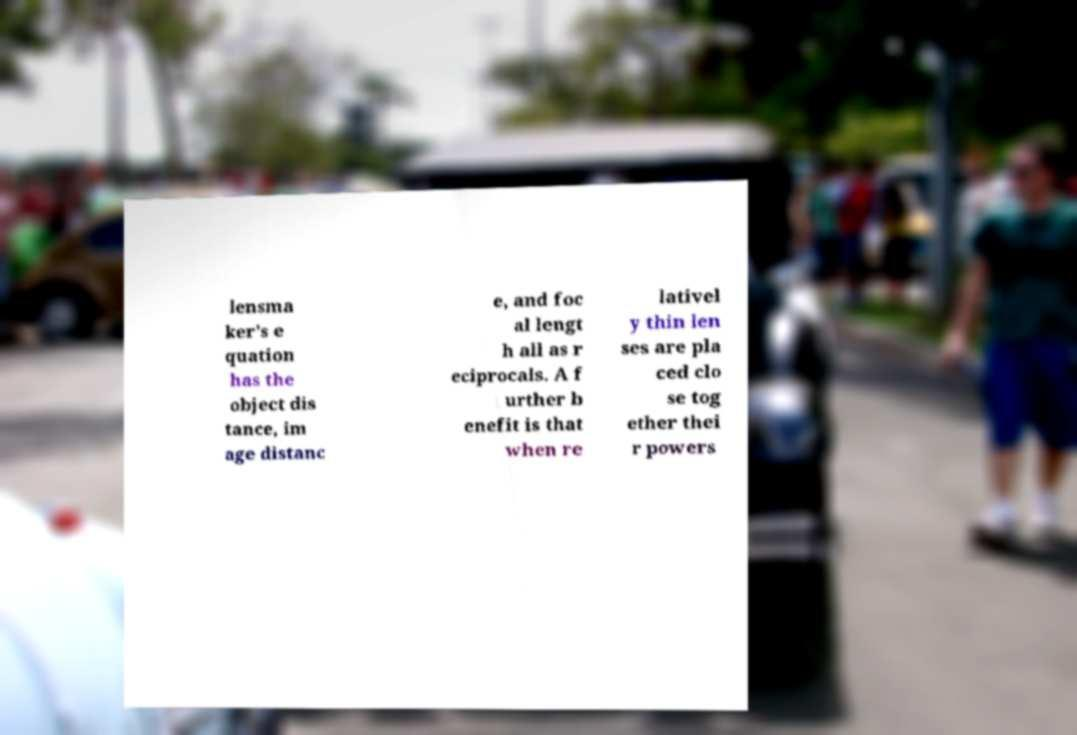What messages or text are displayed in this image? I need them in a readable, typed format. lensma ker's e quation has the object dis tance, im age distanc e, and foc al lengt h all as r eciprocals. A f urther b enefit is that when re lativel y thin len ses are pla ced clo se tog ether thei r powers 